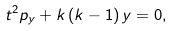Convert formula to latex. <formula><loc_0><loc_0><loc_500><loc_500>t ^ { 2 } p _ { y } + k \, ( k - 1 ) \, y = 0 ,</formula> 